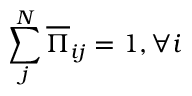<formula> <loc_0><loc_0><loc_500><loc_500>\sum _ { j } ^ { N } \overline { \Pi } _ { i j } = 1 , \forall i</formula> 